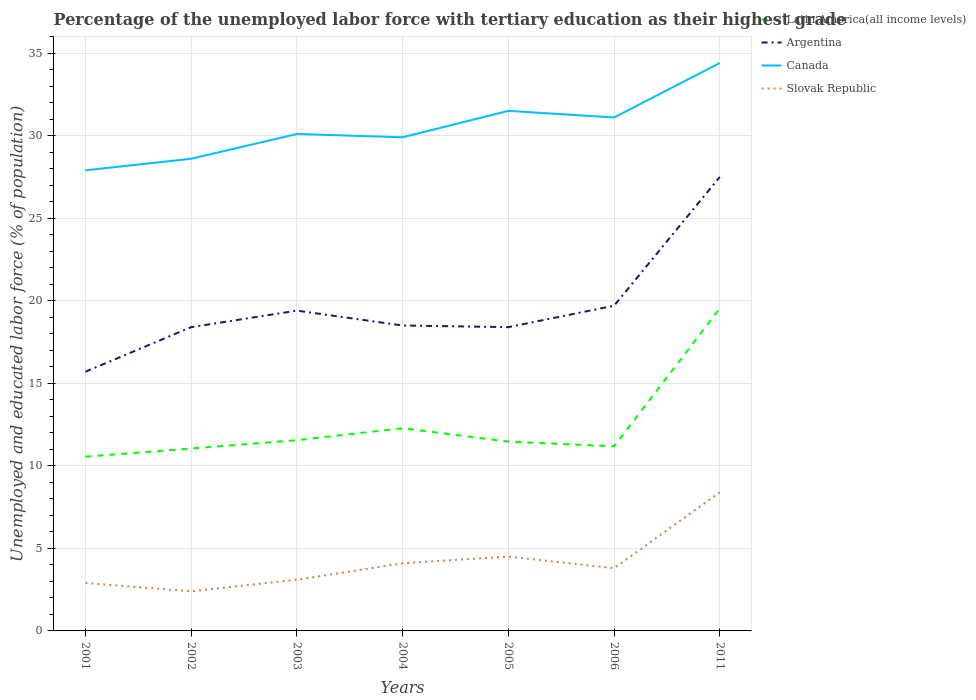Across all years, what is the maximum percentage of the unemployed labor force with tertiary education in Canada?
Provide a succinct answer. 27.9. In which year was the percentage of the unemployed labor force with tertiary education in Latin America(all income levels) maximum?
Your answer should be very brief. 2001. What is the total percentage of the unemployed labor force with tertiary education in Slovak Republic in the graph?
Offer a very short reply. -2.1. What is the difference between the highest and the second highest percentage of the unemployed labor force with tertiary education in Canada?
Provide a succinct answer. 6.5. What is the difference between the highest and the lowest percentage of the unemployed labor force with tertiary education in Canada?
Your response must be concise. 3. Where does the legend appear in the graph?
Offer a terse response. Top right. How many legend labels are there?
Keep it short and to the point. 4. What is the title of the graph?
Give a very brief answer. Percentage of the unemployed labor force with tertiary education as their highest grade. What is the label or title of the X-axis?
Ensure brevity in your answer.  Years. What is the label or title of the Y-axis?
Provide a succinct answer. Unemployed and educated labor force (% of population). What is the Unemployed and educated labor force (% of population) of Latin America(all income levels) in 2001?
Ensure brevity in your answer.  10.55. What is the Unemployed and educated labor force (% of population) in Argentina in 2001?
Ensure brevity in your answer.  15.7. What is the Unemployed and educated labor force (% of population) of Canada in 2001?
Provide a succinct answer. 27.9. What is the Unemployed and educated labor force (% of population) in Slovak Republic in 2001?
Give a very brief answer. 2.9. What is the Unemployed and educated labor force (% of population) of Latin America(all income levels) in 2002?
Keep it short and to the point. 11.05. What is the Unemployed and educated labor force (% of population) of Argentina in 2002?
Offer a very short reply. 18.4. What is the Unemployed and educated labor force (% of population) in Canada in 2002?
Keep it short and to the point. 28.6. What is the Unemployed and educated labor force (% of population) in Slovak Republic in 2002?
Make the answer very short. 2.4. What is the Unemployed and educated labor force (% of population) in Latin America(all income levels) in 2003?
Provide a short and direct response. 11.55. What is the Unemployed and educated labor force (% of population) of Argentina in 2003?
Make the answer very short. 19.4. What is the Unemployed and educated labor force (% of population) of Canada in 2003?
Ensure brevity in your answer.  30.1. What is the Unemployed and educated labor force (% of population) of Slovak Republic in 2003?
Offer a very short reply. 3.1. What is the Unemployed and educated labor force (% of population) in Latin America(all income levels) in 2004?
Offer a very short reply. 12.28. What is the Unemployed and educated labor force (% of population) of Canada in 2004?
Offer a terse response. 29.9. What is the Unemployed and educated labor force (% of population) of Slovak Republic in 2004?
Make the answer very short. 4.1. What is the Unemployed and educated labor force (% of population) of Latin America(all income levels) in 2005?
Your response must be concise. 11.46. What is the Unemployed and educated labor force (% of population) of Argentina in 2005?
Keep it short and to the point. 18.4. What is the Unemployed and educated labor force (% of population) in Canada in 2005?
Offer a very short reply. 31.5. What is the Unemployed and educated labor force (% of population) in Latin America(all income levels) in 2006?
Ensure brevity in your answer.  11.18. What is the Unemployed and educated labor force (% of population) of Argentina in 2006?
Keep it short and to the point. 19.7. What is the Unemployed and educated labor force (% of population) of Canada in 2006?
Ensure brevity in your answer.  31.1. What is the Unemployed and educated labor force (% of population) in Slovak Republic in 2006?
Ensure brevity in your answer.  3.8. What is the Unemployed and educated labor force (% of population) in Latin America(all income levels) in 2011?
Provide a succinct answer. 19.54. What is the Unemployed and educated labor force (% of population) in Canada in 2011?
Provide a short and direct response. 34.4. What is the Unemployed and educated labor force (% of population) of Slovak Republic in 2011?
Make the answer very short. 8.4. Across all years, what is the maximum Unemployed and educated labor force (% of population) in Latin America(all income levels)?
Your response must be concise. 19.54. Across all years, what is the maximum Unemployed and educated labor force (% of population) in Canada?
Offer a terse response. 34.4. Across all years, what is the maximum Unemployed and educated labor force (% of population) in Slovak Republic?
Make the answer very short. 8.4. Across all years, what is the minimum Unemployed and educated labor force (% of population) in Latin America(all income levels)?
Provide a succinct answer. 10.55. Across all years, what is the minimum Unemployed and educated labor force (% of population) of Argentina?
Provide a succinct answer. 15.7. Across all years, what is the minimum Unemployed and educated labor force (% of population) of Canada?
Provide a succinct answer. 27.9. Across all years, what is the minimum Unemployed and educated labor force (% of population) of Slovak Republic?
Ensure brevity in your answer.  2.4. What is the total Unemployed and educated labor force (% of population) of Latin America(all income levels) in the graph?
Your answer should be compact. 87.62. What is the total Unemployed and educated labor force (% of population) of Argentina in the graph?
Give a very brief answer. 137.6. What is the total Unemployed and educated labor force (% of population) of Canada in the graph?
Your answer should be compact. 213.5. What is the total Unemployed and educated labor force (% of population) of Slovak Republic in the graph?
Provide a short and direct response. 29.2. What is the difference between the Unemployed and educated labor force (% of population) in Latin America(all income levels) in 2001 and that in 2002?
Provide a succinct answer. -0.5. What is the difference between the Unemployed and educated labor force (% of population) in Argentina in 2001 and that in 2002?
Provide a short and direct response. -2.7. What is the difference between the Unemployed and educated labor force (% of population) of Canada in 2001 and that in 2002?
Your response must be concise. -0.7. What is the difference between the Unemployed and educated labor force (% of population) in Latin America(all income levels) in 2001 and that in 2003?
Keep it short and to the point. -1. What is the difference between the Unemployed and educated labor force (% of population) in Argentina in 2001 and that in 2003?
Make the answer very short. -3.7. What is the difference between the Unemployed and educated labor force (% of population) of Canada in 2001 and that in 2003?
Provide a succinct answer. -2.2. What is the difference between the Unemployed and educated labor force (% of population) of Slovak Republic in 2001 and that in 2003?
Your response must be concise. -0.2. What is the difference between the Unemployed and educated labor force (% of population) of Latin America(all income levels) in 2001 and that in 2004?
Provide a succinct answer. -1.73. What is the difference between the Unemployed and educated labor force (% of population) in Argentina in 2001 and that in 2004?
Your response must be concise. -2.8. What is the difference between the Unemployed and educated labor force (% of population) in Canada in 2001 and that in 2004?
Your answer should be very brief. -2. What is the difference between the Unemployed and educated labor force (% of population) of Slovak Republic in 2001 and that in 2004?
Give a very brief answer. -1.2. What is the difference between the Unemployed and educated labor force (% of population) in Latin America(all income levels) in 2001 and that in 2005?
Keep it short and to the point. -0.91. What is the difference between the Unemployed and educated labor force (% of population) of Argentina in 2001 and that in 2005?
Offer a terse response. -2.7. What is the difference between the Unemployed and educated labor force (% of population) in Canada in 2001 and that in 2005?
Your answer should be compact. -3.6. What is the difference between the Unemployed and educated labor force (% of population) of Latin America(all income levels) in 2001 and that in 2006?
Offer a terse response. -0.63. What is the difference between the Unemployed and educated labor force (% of population) in Argentina in 2001 and that in 2006?
Your response must be concise. -4. What is the difference between the Unemployed and educated labor force (% of population) of Slovak Republic in 2001 and that in 2006?
Your answer should be very brief. -0.9. What is the difference between the Unemployed and educated labor force (% of population) in Latin America(all income levels) in 2001 and that in 2011?
Offer a very short reply. -8.98. What is the difference between the Unemployed and educated labor force (% of population) of Argentina in 2001 and that in 2011?
Keep it short and to the point. -11.8. What is the difference between the Unemployed and educated labor force (% of population) of Canada in 2001 and that in 2011?
Provide a succinct answer. -6.5. What is the difference between the Unemployed and educated labor force (% of population) of Latin America(all income levels) in 2002 and that in 2003?
Offer a terse response. -0.51. What is the difference between the Unemployed and educated labor force (% of population) of Latin America(all income levels) in 2002 and that in 2004?
Offer a terse response. -1.23. What is the difference between the Unemployed and educated labor force (% of population) in Argentina in 2002 and that in 2004?
Ensure brevity in your answer.  -0.1. What is the difference between the Unemployed and educated labor force (% of population) of Slovak Republic in 2002 and that in 2004?
Provide a succinct answer. -1.7. What is the difference between the Unemployed and educated labor force (% of population) of Latin America(all income levels) in 2002 and that in 2005?
Ensure brevity in your answer.  -0.42. What is the difference between the Unemployed and educated labor force (% of population) of Argentina in 2002 and that in 2005?
Your answer should be very brief. 0. What is the difference between the Unemployed and educated labor force (% of population) in Canada in 2002 and that in 2005?
Provide a succinct answer. -2.9. What is the difference between the Unemployed and educated labor force (% of population) of Slovak Republic in 2002 and that in 2005?
Keep it short and to the point. -2.1. What is the difference between the Unemployed and educated labor force (% of population) of Latin America(all income levels) in 2002 and that in 2006?
Provide a short and direct response. -0.14. What is the difference between the Unemployed and educated labor force (% of population) of Argentina in 2002 and that in 2006?
Provide a succinct answer. -1.3. What is the difference between the Unemployed and educated labor force (% of population) in Slovak Republic in 2002 and that in 2006?
Ensure brevity in your answer.  -1.4. What is the difference between the Unemployed and educated labor force (% of population) in Latin America(all income levels) in 2002 and that in 2011?
Offer a very short reply. -8.49. What is the difference between the Unemployed and educated labor force (% of population) of Latin America(all income levels) in 2003 and that in 2004?
Provide a succinct answer. -0.73. What is the difference between the Unemployed and educated labor force (% of population) of Argentina in 2003 and that in 2004?
Your response must be concise. 0.9. What is the difference between the Unemployed and educated labor force (% of population) in Canada in 2003 and that in 2004?
Your answer should be very brief. 0.2. What is the difference between the Unemployed and educated labor force (% of population) of Slovak Republic in 2003 and that in 2004?
Provide a short and direct response. -1. What is the difference between the Unemployed and educated labor force (% of population) in Latin America(all income levels) in 2003 and that in 2005?
Offer a very short reply. 0.09. What is the difference between the Unemployed and educated labor force (% of population) of Canada in 2003 and that in 2005?
Give a very brief answer. -1.4. What is the difference between the Unemployed and educated labor force (% of population) of Latin America(all income levels) in 2003 and that in 2006?
Make the answer very short. 0.37. What is the difference between the Unemployed and educated labor force (% of population) in Canada in 2003 and that in 2006?
Make the answer very short. -1. What is the difference between the Unemployed and educated labor force (% of population) of Latin America(all income levels) in 2003 and that in 2011?
Offer a terse response. -7.98. What is the difference between the Unemployed and educated labor force (% of population) of Slovak Republic in 2003 and that in 2011?
Provide a succinct answer. -5.3. What is the difference between the Unemployed and educated labor force (% of population) of Latin America(all income levels) in 2004 and that in 2005?
Provide a succinct answer. 0.81. What is the difference between the Unemployed and educated labor force (% of population) of Argentina in 2004 and that in 2005?
Keep it short and to the point. 0.1. What is the difference between the Unemployed and educated labor force (% of population) in Slovak Republic in 2004 and that in 2005?
Offer a terse response. -0.4. What is the difference between the Unemployed and educated labor force (% of population) of Latin America(all income levels) in 2004 and that in 2006?
Your response must be concise. 1.09. What is the difference between the Unemployed and educated labor force (% of population) in Argentina in 2004 and that in 2006?
Your answer should be very brief. -1.2. What is the difference between the Unemployed and educated labor force (% of population) of Latin America(all income levels) in 2004 and that in 2011?
Offer a terse response. -7.26. What is the difference between the Unemployed and educated labor force (% of population) in Canada in 2004 and that in 2011?
Make the answer very short. -4.5. What is the difference between the Unemployed and educated labor force (% of population) of Slovak Republic in 2004 and that in 2011?
Give a very brief answer. -4.3. What is the difference between the Unemployed and educated labor force (% of population) in Latin America(all income levels) in 2005 and that in 2006?
Your answer should be compact. 0.28. What is the difference between the Unemployed and educated labor force (% of population) of Canada in 2005 and that in 2006?
Keep it short and to the point. 0.4. What is the difference between the Unemployed and educated labor force (% of population) in Slovak Republic in 2005 and that in 2006?
Offer a terse response. 0.7. What is the difference between the Unemployed and educated labor force (% of population) of Latin America(all income levels) in 2005 and that in 2011?
Make the answer very short. -8.07. What is the difference between the Unemployed and educated labor force (% of population) of Argentina in 2005 and that in 2011?
Offer a terse response. -9.1. What is the difference between the Unemployed and educated labor force (% of population) in Canada in 2005 and that in 2011?
Give a very brief answer. -2.9. What is the difference between the Unemployed and educated labor force (% of population) in Slovak Republic in 2005 and that in 2011?
Your answer should be compact. -3.9. What is the difference between the Unemployed and educated labor force (% of population) in Latin America(all income levels) in 2006 and that in 2011?
Your answer should be compact. -8.35. What is the difference between the Unemployed and educated labor force (% of population) of Argentina in 2006 and that in 2011?
Offer a very short reply. -7.8. What is the difference between the Unemployed and educated labor force (% of population) in Slovak Republic in 2006 and that in 2011?
Offer a terse response. -4.6. What is the difference between the Unemployed and educated labor force (% of population) in Latin America(all income levels) in 2001 and the Unemployed and educated labor force (% of population) in Argentina in 2002?
Give a very brief answer. -7.85. What is the difference between the Unemployed and educated labor force (% of population) in Latin America(all income levels) in 2001 and the Unemployed and educated labor force (% of population) in Canada in 2002?
Give a very brief answer. -18.05. What is the difference between the Unemployed and educated labor force (% of population) of Latin America(all income levels) in 2001 and the Unemployed and educated labor force (% of population) of Slovak Republic in 2002?
Your response must be concise. 8.15. What is the difference between the Unemployed and educated labor force (% of population) in Latin America(all income levels) in 2001 and the Unemployed and educated labor force (% of population) in Argentina in 2003?
Make the answer very short. -8.85. What is the difference between the Unemployed and educated labor force (% of population) in Latin America(all income levels) in 2001 and the Unemployed and educated labor force (% of population) in Canada in 2003?
Provide a short and direct response. -19.55. What is the difference between the Unemployed and educated labor force (% of population) of Latin America(all income levels) in 2001 and the Unemployed and educated labor force (% of population) of Slovak Republic in 2003?
Keep it short and to the point. 7.45. What is the difference between the Unemployed and educated labor force (% of population) in Argentina in 2001 and the Unemployed and educated labor force (% of population) in Canada in 2003?
Provide a succinct answer. -14.4. What is the difference between the Unemployed and educated labor force (% of population) of Argentina in 2001 and the Unemployed and educated labor force (% of population) of Slovak Republic in 2003?
Offer a terse response. 12.6. What is the difference between the Unemployed and educated labor force (% of population) in Canada in 2001 and the Unemployed and educated labor force (% of population) in Slovak Republic in 2003?
Offer a very short reply. 24.8. What is the difference between the Unemployed and educated labor force (% of population) of Latin America(all income levels) in 2001 and the Unemployed and educated labor force (% of population) of Argentina in 2004?
Your answer should be very brief. -7.95. What is the difference between the Unemployed and educated labor force (% of population) of Latin America(all income levels) in 2001 and the Unemployed and educated labor force (% of population) of Canada in 2004?
Offer a terse response. -19.35. What is the difference between the Unemployed and educated labor force (% of population) in Latin America(all income levels) in 2001 and the Unemployed and educated labor force (% of population) in Slovak Republic in 2004?
Your answer should be very brief. 6.45. What is the difference between the Unemployed and educated labor force (% of population) of Argentina in 2001 and the Unemployed and educated labor force (% of population) of Slovak Republic in 2004?
Your answer should be very brief. 11.6. What is the difference between the Unemployed and educated labor force (% of population) of Canada in 2001 and the Unemployed and educated labor force (% of population) of Slovak Republic in 2004?
Keep it short and to the point. 23.8. What is the difference between the Unemployed and educated labor force (% of population) of Latin America(all income levels) in 2001 and the Unemployed and educated labor force (% of population) of Argentina in 2005?
Give a very brief answer. -7.85. What is the difference between the Unemployed and educated labor force (% of population) in Latin America(all income levels) in 2001 and the Unemployed and educated labor force (% of population) in Canada in 2005?
Ensure brevity in your answer.  -20.95. What is the difference between the Unemployed and educated labor force (% of population) of Latin America(all income levels) in 2001 and the Unemployed and educated labor force (% of population) of Slovak Republic in 2005?
Make the answer very short. 6.05. What is the difference between the Unemployed and educated labor force (% of population) of Argentina in 2001 and the Unemployed and educated labor force (% of population) of Canada in 2005?
Your answer should be very brief. -15.8. What is the difference between the Unemployed and educated labor force (% of population) of Canada in 2001 and the Unemployed and educated labor force (% of population) of Slovak Republic in 2005?
Offer a terse response. 23.4. What is the difference between the Unemployed and educated labor force (% of population) of Latin America(all income levels) in 2001 and the Unemployed and educated labor force (% of population) of Argentina in 2006?
Ensure brevity in your answer.  -9.15. What is the difference between the Unemployed and educated labor force (% of population) in Latin America(all income levels) in 2001 and the Unemployed and educated labor force (% of population) in Canada in 2006?
Your answer should be compact. -20.55. What is the difference between the Unemployed and educated labor force (% of population) in Latin America(all income levels) in 2001 and the Unemployed and educated labor force (% of population) in Slovak Republic in 2006?
Your answer should be compact. 6.75. What is the difference between the Unemployed and educated labor force (% of population) in Argentina in 2001 and the Unemployed and educated labor force (% of population) in Canada in 2006?
Keep it short and to the point. -15.4. What is the difference between the Unemployed and educated labor force (% of population) of Argentina in 2001 and the Unemployed and educated labor force (% of population) of Slovak Republic in 2006?
Your answer should be very brief. 11.9. What is the difference between the Unemployed and educated labor force (% of population) of Canada in 2001 and the Unemployed and educated labor force (% of population) of Slovak Republic in 2006?
Make the answer very short. 24.1. What is the difference between the Unemployed and educated labor force (% of population) of Latin America(all income levels) in 2001 and the Unemployed and educated labor force (% of population) of Argentina in 2011?
Offer a very short reply. -16.95. What is the difference between the Unemployed and educated labor force (% of population) in Latin America(all income levels) in 2001 and the Unemployed and educated labor force (% of population) in Canada in 2011?
Give a very brief answer. -23.85. What is the difference between the Unemployed and educated labor force (% of population) of Latin America(all income levels) in 2001 and the Unemployed and educated labor force (% of population) of Slovak Republic in 2011?
Offer a very short reply. 2.15. What is the difference between the Unemployed and educated labor force (% of population) in Argentina in 2001 and the Unemployed and educated labor force (% of population) in Canada in 2011?
Your answer should be compact. -18.7. What is the difference between the Unemployed and educated labor force (% of population) of Argentina in 2001 and the Unemployed and educated labor force (% of population) of Slovak Republic in 2011?
Provide a short and direct response. 7.3. What is the difference between the Unemployed and educated labor force (% of population) in Latin America(all income levels) in 2002 and the Unemployed and educated labor force (% of population) in Argentina in 2003?
Your response must be concise. -8.35. What is the difference between the Unemployed and educated labor force (% of population) of Latin America(all income levels) in 2002 and the Unemployed and educated labor force (% of population) of Canada in 2003?
Offer a very short reply. -19.05. What is the difference between the Unemployed and educated labor force (% of population) of Latin America(all income levels) in 2002 and the Unemployed and educated labor force (% of population) of Slovak Republic in 2003?
Keep it short and to the point. 7.95. What is the difference between the Unemployed and educated labor force (% of population) of Argentina in 2002 and the Unemployed and educated labor force (% of population) of Slovak Republic in 2003?
Provide a succinct answer. 15.3. What is the difference between the Unemployed and educated labor force (% of population) in Latin America(all income levels) in 2002 and the Unemployed and educated labor force (% of population) in Argentina in 2004?
Ensure brevity in your answer.  -7.45. What is the difference between the Unemployed and educated labor force (% of population) of Latin America(all income levels) in 2002 and the Unemployed and educated labor force (% of population) of Canada in 2004?
Ensure brevity in your answer.  -18.85. What is the difference between the Unemployed and educated labor force (% of population) in Latin America(all income levels) in 2002 and the Unemployed and educated labor force (% of population) in Slovak Republic in 2004?
Provide a succinct answer. 6.95. What is the difference between the Unemployed and educated labor force (% of population) in Canada in 2002 and the Unemployed and educated labor force (% of population) in Slovak Republic in 2004?
Your response must be concise. 24.5. What is the difference between the Unemployed and educated labor force (% of population) of Latin America(all income levels) in 2002 and the Unemployed and educated labor force (% of population) of Argentina in 2005?
Your answer should be very brief. -7.35. What is the difference between the Unemployed and educated labor force (% of population) in Latin America(all income levels) in 2002 and the Unemployed and educated labor force (% of population) in Canada in 2005?
Your answer should be compact. -20.45. What is the difference between the Unemployed and educated labor force (% of population) of Latin America(all income levels) in 2002 and the Unemployed and educated labor force (% of population) of Slovak Republic in 2005?
Ensure brevity in your answer.  6.55. What is the difference between the Unemployed and educated labor force (% of population) in Argentina in 2002 and the Unemployed and educated labor force (% of population) in Canada in 2005?
Keep it short and to the point. -13.1. What is the difference between the Unemployed and educated labor force (% of population) in Canada in 2002 and the Unemployed and educated labor force (% of population) in Slovak Republic in 2005?
Your answer should be compact. 24.1. What is the difference between the Unemployed and educated labor force (% of population) in Latin America(all income levels) in 2002 and the Unemployed and educated labor force (% of population) in Argentina in 2006?
Offer a terse response. -8.65. What is the difference between the Unemployed and educated labor force (% of population) in Latin America(all income levels) in 2002 and the Unemployed and educated labor force (% of population) in Canada in 2006?
Offer a terse response. -20.05. What is the difference between the Unemployed and educated labor force (% of population) of Latin America(all income levels) in 2002 and the Unemployed and educated labor force (% of population) of Slovak Republic in 2006?
Offer a terse response. 7.25. What is the difference between the Unemployed and educated labor force (% of population) of Argentina in 2002 and the Unemployed and educated labor force (% of population) of Canada in 2006?
Give a very brief answer. -12.7. What is the difference between the Unemployed and educated labor force (% of population) in Canada in 2002 and the Unemployed and educated labor force (% of population) in Slovak Republic in 2006?
Keep it short and to the point. 24.8. What is the difference between the Unemployed and educated labor force (% of population) in Latin America(all income levels) in 2002 and the Unemployed and educated labor force (% of population) in Argentina in 2011?
Make the answer very short. -16.45. What is the difference between the Unemployed and educated labor force (% of population) of Latin America(all income levels) in 2002 and the Unemployed and educated labor force (% of population) of Canada in 2011?
Your response must be concise. -23.35. What is the difference between the Unemployed and educated labor force (% of population) in Latin America(all income levels) in 2002 and the Unemployed and educated labor force (% of population) in Slovak Republic in 2011?
Offer a terse response. 2.65. What is the difference between the Unemployed and educated labor force (% of population) in Argentina in 2002 and the Unemployed and educated labor force (% of population) in Canada in 2011?
Offer a very short reply. -16. What is the difference between the Unemployed and educated labor force (% of population) in Canada in 2002 and the Unemployed and educated labor force (% of population) in Slovak Republic in 2011?
Your response must be concise. 20.2. What is the difference between the Unemployed and educated labor force (% of population) of Latin America(all income levels) in 2003 and the Unemployed and educated labor force (% of population) of Argentina in 2004?
Offer a very short reply. -6.95. What is the difference between the Unemployed and educated labor force (% of population) in Latin America(all income levels) in 2003 and the Unemployed and educated labor force (% of population) in Canada in 2004?
Make the answer very short. -18.35. What is the difference between the Unemployed and educated labor force (% of population) of Latin America(all income levels) in 2003 and the Unemployed and educated labor force (% of population) of Slovak Republic in 2004?
Offer a very short reply. 7.45. What is the difference between the Unemployed and educated labor force (% of population) in Argentina in 2003 and the Unemployed and educated labor force (% of population) in Canada in 2004?
Make the answer very short. -10.5. What is the difference between the Unemployed and educated labor force (% of population) in Argentina in 2003 and the Unemployed and educated labor force (% of population) in Slovak Republic in 2004?
Provide a short and direct response. 15.3. What is the difference between the Unemployed and educated labor force (% of population) of Latin America(all income levels) in 2003 and the Unemployed and educated labor force (% of population) of Argentina in 2005?
Provide a succinct answer. -6.85. What is the difference between the Unemployed and educated labor force (% of population) in Latin America(all income levels) in 2003 and the Unemployed and educated labor force (% of population) in Canada in 2005?
Ensure brevity in your answer.  -19.95. What is the difference between the Unemployed and educated labor force (% of population) of Latin America(all income levels) in 2003 and the Unemployed and educated labor force (% of population) of Slovak Republic in 2005?
Make the answer very short. 7.05. What is the difference between the Unemployed and educated labor force (% of population) in Argentina in 2003 and the Unemployed and educated labor force (% of population) in Canada in 2005?
Provide a short and direct response. -12.1. What is the difference between the Unemployed and educated labor force (% of population) in Canada in 2003 and the Unemployed and educated labor force (% of population) in Slovak Republic in 2005?
Keep it short and to the point. 25.6. What is the difference between the Unemployed and educated labor force (% of population) of Latin America(all income levels) in 2003 and the Unemployed and educated labor force (% of population) of Argentina in 2006?
Offer a terse response. -8.15. What is the difference between the Unemployed and educated labor force (% of population) in Latin America(all income levels) in 2003 and the Unemployed and educated labor force (% of population) in Canada in 2006?
Provide a succinct answer. -19.55. What is the difference between the Unemployed and educated labor force (% of population) of Latin America(all income levels) in 2003 and the Unemployed and educated labor force (% of population) of Slovak Republic in 2006?
Your answer should be compact. 7.75. What is the difference between the Unemployed and educated labor force (% of population) in Argentina in 2003 and the Unemployed and educated labor force (% of population) in Slovak Republic in 2006?
Your answer should be very brief. 15.6. What is the difference between the Unemployed and educated labor force (% of population) in Canada in 2003 and the Unemployed and educated labor force (% of population) in Slovak Republic in 2006?
Offer a terse response. 26.3. What is the difference between the Unemployed and educated labor force (% of population) in Latin America(all income levels) in 2003 and the Unemployed and educated labor force (% of population) in Argentina in 2011?
Offer a very short reply. -15.95. What is the difference between the Unemployed and educated labor force (% of population) in Latin America(all income levels) in 2003 and the Unemployed and educated labor force (% of population) in Canada in 2011?
Offer a very short reply. -22.85. What is the difference between the Unemployed and educated labor force (% of population) in Latin America(all income levels) in 2003 and the Unemployed and educated labor force (% of population) in Slovak Republic in 2011?
Give a very brief answer. 3.15. What is the difference between the Unemployed and educated labor force (% of population) of Canada in 2003 and the Unemployed and educated labor force (% of population) of Slovak Republic in 2011?
Your answer should be very brief. 21.7. What is the difference between the Unemployed and educated labor force (% of population) in Latin America(all income levels) in 2004 and the Unemployed and educated labor force (% of population) in Argentina in 2005?
Make the answer very short. -6.12. What is the difference between the Unemployed and educated labor force (% of population) in Latin America(all income levels) in 2004 and the Unemployed and educated labor force (% of population) in Canada in 2005?
Your answer should be compact. -19.22. What is the difference between the Unemployed and educated labor force (% of population) of Latin America(all income levels) in 2004 and the Unemployed and educated labor force (% of population) of Slovak Republic in 2005?
Make the answer very short. 7.78. What is the difference between the Unemployed and educated labor force (% of population) in Argentina in 2004 and the Unemployed and educated labor force (% of population) in Canada in 2005?
Make the answer very short. -13. What is the difference between the Unemployed and educated labor force (% of population) of Argentina in 2004 and the Unemployed and educated labor force (% of population) of Slovak Republic in 2005?
Offer a very short reply. 14. What is the difference between the Unemployed and educated labor force (% of population) of Canada in 2004 and the Unemployed and educated labor force (% of population) of Slovak Republic in 2005?
Give a very brief answer. 25.4. What is the difference between the Unemployed and educated labor force (% of population) of Latin America(all income levels) in 2004 and the Unemployed and educated labor force (% of population) of Argentina in 2006?
Keep it short and to the point. -7.42. What is the difference between the Unemployed and educated labor force (% of population) of Latin America(all income levels) in 2004 and the Unemployed and educated labor force (% of population) of Canada in 2006?
Offer a very short reply. -18.82. What is the difference between the Unemployed and educated labor force (% of population) in Latin America(all income levels) in 2004 and the Unemployed and educated labor force (% of population) in Slovak Republic in 2006?
Make the answer very short. 8.48. What is the difference between the Unemployed and educated labor force (% of population) of Argentina in 2004 and the Unemployed and educated labor force (% of population) of Canada in 2006?
Provide a short and direct response. -12.6. What is the difference between the Unemployed and educated labor force (% of population) in Canada in 2004 and the Unemployed and educated labor force (% of population) in Slovak Republic in 2006?
Provide a short and direct response. 26.1. What is the difference between the Unemployed and educated labor force (% of population) in Latin America(all income levels) in 2004 and the Unemployed and educated labor force (% of population) in Argentina in 2011?
Give a very brief answer. -15.22. What is the difference between the Unemployed and educated labor force (% of population) in Latin America(all income levels) in 2004 and the Unemployed and educated labor force (% of population) in Canada in 2011?
Your answer should be very brief. -22.12. What is the difference between the Unemployed and educated labor force (% of population) in Latin America(all income levels) in 2004 and the Unemployed and educated labor force (% of population) in Slovak Republic in 2011?
Give a very brief answer. 3.88. What is the difference between the Unemployed and educated labor force (% of population) of Argentina in 2004 and the Unemployed and educated labor force (% of population) of Canada in 2011?
Your response must be concise. -15.9. What is the difference between the Unemployed and educated labor force (% of population) in Canada in 2004 and the Unemployed and educated labor force (% of population) in Slovak Republic in 2011?
Offer a very short reply. 21.5. What is the difference between the Unemployed and educated labor force (% of population) in Latin America(all income levels) in 2005 and the Unemployed and educated labor force (% of population) in Argentina in 2006?
Provide a succinct answer. -8.24. What is the difference between the Unemployed and educated labor force (% of population) of Latin America(all income levels) in 2005 and the Unemployed and educated labor force (% of population) of Canada in 2006?
Offer a very short reply. -19.64. What is the difference between the Unemployed and educated labor force (% of population) of Latin America(all income levels) in 2005 and the Unemployed and educated labor force (% of population) of Slovak Republic in 2006?
Offer a very short reply. 7.66. What is the difference between the Unemployed and educated labor force (% of population) in Argentina in 2005 and the Unemployed and educated labor force (% of population) in Canada in 2006?
Make the answer very short. -12.7. What is the difference between the Unemployed and educated labor force (% of population) in Argentina in 2005 and the Unemployed and educated labor force (% of population) in Slovak Republic in 2006?
Your answer should be very brief. 14.6. What is the difference between the Unemployed and educated labor force (% of population) of Canada in 2005 and the Unemployed and educated labor force (% of population) of Slovak Republic in 2006?
Your answer should be compact. 27.7. What is the difference between the Unemployed and educated labor force (% of population) of Latin America(all income levels) in 2005 and the Unemployed and educated labor force (% of population) of Argentina in 2011?
Offer a terse response. -16.04. What is the difference between the Unemployed and educated labor force (% of population) in Latin America(all income levels) in 2005 and the Unemployed and educated labor force (% of population) in Canada in 2011?
Your answer should be compact. -22.94. What is the difference between the Unemployed and educated labor force (% of population) in Latin America(all income levels) in 2005 and the Unemployed and educated labor force (% of population) in Slovak Republic in 2011?
Keep it short and to the point. 3.06. What is the difference between the Unemployed and educated labor force (% of population) in Canada in 2005 and the Unemployed and educated labor force (% of population) in Slovak Republic in 2011?
Provide a short and direct response. 23.1. What is the difference between the Unemployed and educated labor force (% of population) of Latin America(all income levels) in 2006 and the Unemployed and educated labor force (% of population) of Argentina in 2011?
Ensure brevity in your answer.  -16.32. What is the difference between the Unemployed and educated labor force (% of population) in Latin America(all income levels) in 2006 and the Unemployed and educated labor force (% of population) in Canada in 2011?
Your answer should be compact. -23.22. What is the difference between the Unemployed and educated labor force (% of population) of Latin America(all income levels) in 2006 and the Unemployed and educated labor force (% of population) of Slovak Republic in 2011?
Give a very brief answer. 2.78. What is the difference between the Unemployed and educated labor force (% of population) in Argentina in 2006 and the Unemployed and educated labor force (% of population) in Canada in 2011?
Provide a short and direct response. -14.7. What is the difference between the Unemployed and educated labor force (% of population) in Argentina in 2006 and the Unemployed and educated labor force (% of population) in Slovak Republic in 2011?
Ensure brevity in your answer.  11.3. What is the difference between the Unemployed and educated labor force (% of population) in Canada in 2006 and the Unemployed and educated labor force (% of population) in Slovak Republic in 2011?
Offer a terse response. 22.7. What is the average Unemployed and educated labor force (% of population) of Latin America(all income levels) per year?
Offer a terse response. 12.52. What is the average Unemployed and educated labor force (% of population) of Argentina per year?
Offer a very short reply. 19.66. What is the average Unemployed and educated labor force (% of population) in Canada per year?
Provide a succinct answer. 30.5. What is the average Unemployed and educated labor force (% of population) of Slovak Republic per year?
Offer a terse response. 4.17. In the year 2001, what is the difference between the Unemployed and educated labor force (% of population) in Latin America(all income levels) and Unemployed and educated labor force (% of population) in Argentina?
Keep it short and to the point. -5.15. In the year 2001, what is the difference between the Unemployed and educated labor force (% of population) in Latin America(all income levels) and Unemployed and educated labor force (% of population) in Canada?
Ensure brevity in your answer.  -17.35. In the year 2001, what is the difference between the Unemployed and educated labor force (% of population) in Latin America(all income levels) and Unemployed and educated labor force (% of population) in Slovak Republic?
Give a very brief answer. 7.65. In the year 2001, what is the difference between the Unemployed and educated labor force (% of population) of Argentina and Unemployed and educated labor force (% of population) of Canada?
Your answer should be compact. -12.2. In the year 2001, what is the difference between the Unemployed and educated labor force (% of population) of Argentina and Unemployed and educated labor force (% of population) of Slovak Republic?
Offer a very short reply. 12.8. In the year 2001, what is the difference between the Unemployed and educated labor force (% of population) in Canada and Unemployed and educated labor force (% of population) in Slovak Republic?
Your answer should be compact. 25. In the year 2002, what is the difference between the Unemployed and educated labor force (% of population) in Latin America(all income levels) and Unemployed and educated labor force (% of population) in Argentina?
Your answer should be compact. -7.35. In the year 2002, what is the difference between the Unemployed and educated labor force (% of population) in Latin America(all income levels) and Unemployed and educated labor force (% of population) in Canada?
Your answer should be very brief. -17.55. In the year 2002, what is the difference between the Unemployed and educated labor force (% of population) of Latin America(all income levels) and Unemployed and educated labor force (% of population) of Slovak Republic?
Provide a short and direct response. 8.65. In the year 2002, what is the difference between the Unemployed and educated labor force (% of population) in Canada and Unemployed and educated labor force (% of population) in Slovak Republic?
Give a very brief answer. 26.2. In the year 2003, what is the difference between the Unemployed and educated labor force (% of population) in Latin America(all income levels) and Unemployed and educated labor force (% of population) in Argentina?
Offer a terse response. -7.85. In the year 2003, what is the difference between the Unemployed and educated labor force (% of population) in Latin America(all income levels) and Unemployed and educated labor force (% of population) in Canada?
Make the answer very short. -18.55. In the year 2003, what is the difference between the Unemployed and educated labor force (% of population) of Latin America(all income levels) and Unemployed and educated labor force (% of population) of Slovak Republic?
Give a very brief answer. 8.45. In the year 2003, what is the difference between the Unemployed and educated labor force (% of population) of Argentina and Unemployed and educated labor force (% of population) of Slovak Republic?
Ensure brevity in your answer.  16.3. In the year 2004, what is the difference between the Unemployed and educated labor force (% of population) of Latin America(all income levels) and Unemployed and educated labor force (% of population) of Argentina?
Your response must be concise. -6.22. In the year 2004, what is the difference between the Unemployed and educated labor force (% of population) of Latin America(all income levels) and Unemployed and educated labor force (% of population) of Canada?
Make the answer very short. -17.62. In the year 2004, what is the difference between the Unemployed and educated labor force (% of population) in Latin America(all income levels) and Unemployed and educated labor force (% of population) in Slovak Republic?
Your response must be concise. 8.18. In the year 2004, what is the difference between the Unemployed and educated labor force (% of population) of Argentina and Unemployed and educated labor force (% of population) of Canada?
Make the answer very short. -11.4. In the year 2004, what is the difference between the Unemployed and educated labor force (% of population) in Argentina and Unemployed and educated labor force (% of population) in Slovak Republic?
Provide a short and direct response. 14.4. In the year 2004, what is the difference between the Unemployed and educated labor force (% of population) in Canada and Unemployed and educated labor force (% of population) in Slovak Republic?
Keep it short and to the point. 25.8. In the year 2005, what is the difference between the Unemployed and educated labor force (% of population) of Latin America(all income levels) and Unemployed and educated labor force (% of population) of Argentina?
Provide a succinct answer. -6.94. In the year 2005, what is the difference between the Unemployed and educated labor force (% of population) of Latin America(all income levels) and Unemployed and educated labor force (% of population) of Canada?
Your response must be concise. -20.04. In the year 2005, what is the difference between the Unemployed and educated labor force (% of population) of Latin America(all income levels) and Unemployed and educated labor force (% of population) of Slovak Republic?
Your response must be concise. 6.96. In the year 2005, what is the difference between the Unemployed and educated labor force (% of population) of Argentina and Unemployed and educated labor force (% of population) of Canada?
Provide a short and direct response. -13.1. In the year 2005, what is the difference between the Unemployed and educated labor force (% of population) of Argentina and Unemployed and educated labor force (% of population) of Slovak Republic?
Provide a short and direct response. 13.9. In the year 2005, what is the difference between the Unemployed and educated labor force (% of population) in Canada and Unemployed and educated labor force (% of population) in Slovak Republic?
Offer a very short reply. 27. In the year 2006, what is the difference between the Unemployed and educated labor force (% of population) of Latin America(all income levels) and Unemployed and educated labor force (% of population) of Argentina?
Offer a terse response. -8.52. In the year 2006, what is the difference between the Unemployed and educated labor force (% of population) in Latin America(all income levels) and Unemployed and educated labor force (% of population) in Canada?
Your response must be concise. -19.92. In the year 2006, what is the difference between the Unemployed and educated labor force (% of population) of Latin America(all income levels) and Unemployed and educated labor force (% of population) of Slovak Republic?
Provide a succinct answer. 7.38. In the year 2006, what is the difference between the Unemployed and educated labor force (% of population) in Argentina and Unemployed and educated labor force (% of population) in Canada?
Give a very brief answer. -11.4. In the year 2006, what is the difference between the Unemployed and educated labor force (% of population) in Argentina and Unemployed and educated labor force (% of population) in Slovak Republic?
Provide a succinct answer. 15.9. In the year 2006, what is the difference between the Unemployed and educated labor force (% of population) in Canada and Unemployed and educated labor force (% of population) in Slovak Republic?
Keep it short and to the point. 27.3. In the year 2011, what is the difference between the Unemployed and educated labor force (% of population) of Latin America(all income levels) and Unemployed and educated labor force (% of population) of Argentina?
Offer a terse response. -7.96. In the year 2011, what is the difference between the Unemployed and educated labor force (% of population) of Latin America(all income levels) and Unemployed and educated labor force (% of population) of Canada?
Your response must be concise. -14.86. In the year 2011, what is the difference between the Unemployed and educated labor force (% of population) of Latin America(all income levels) and Unemployed and educated labor force (% of population) of Slovak Republic?
Provide a succinct answer. 11.14. In the year 2011, what is the difference between the Unemployed and educated labor force (% of population) of Argentina and Unemployed and educated labor force (% of population) of Canada?
Provide a succinct answer. -6.9. In the year 2011, what is the difference between the Unemployed and educated labor force (% of population) of Argentina and Unemployed and educated labor force (% of population) of Slovak Republic?
Make the answer very short. 19.1. What is the ratio of the Unemployed and educated labor force (% of population) of Latin America(all income levels) in 2001 to that in 2002?
Provide a succinct answer. 0.96. What is the ratio of the Unemployed and educated labor force (% of population) of Argentina in 2001 to that in 2002?
Offer a very short reply. 0.85. What is the ratio of the Unemployed and educated labor force (% of population) in Canada in 2001 to that in 2002?
Ensure brevity in your answer.  0.98. What is the ratio of the Unemployed and educated labor force (% of population) in Slovak Republic in 2001 to that in 2002?
Offer a terse response. 1.21. What is the ratio of the Unemployed and educated labor force (% of population) in Latin America(all income levels) in 2001 to that in 2003?
Make the answer very short. 0.91. What is the ratio of the Unemployed and educated labor force (% of population) in Argentina in 2001 to that in 2003?
Your response must be concise. 0.81. What is the ratio of the Unemployed and educated labor force (% of population) of Canada in 2001 to that in 2003?
Give a very brief answer. 0.93. What is the ratio of the Unemployed and educated labor force (% of population) of Slovak Republic in 2001 to that in 2003?
Give a very brief answer. 0.94. What is the ratio of the Unemployed and educated labor force (% of population) in Latin America(all income levels) in 2001 to that in 2004?
Your answer should be compact. 0.86. What is the ratio of the Unemployed and educated labor force (% of population) in Argentina in 2001 to that in 2004?
Make the answer very short. 0.85. What is the ratio of the Unemployed and educated labor force (% of population) of Canada in 2001 to that in 2004?
Offer a terse response. 0.93. What is the ratio of the Unemployed and educated labor force (% of population) of Slovak Republic in 2001 to that in 2004?
Provide a short and direct response. 0.71. What is the ratio of the Unemployed and educated labor force (% of population) in Latin America(all income levels) in 2001 to that in 2005?
Provide a short and direct response. 0.92. What is the ratio of the Unemployed and educated labor force (% of population) in Argentina in 2001 to that in 2005?
Your answer should be very brief. 0.85. What is the ratio of the Unemployed and educated labor force (% of population) in Canada in 2001 to that in 2005?
Provide a short and direct response. 0.89. What is the ratio of the Unemployed and educated labor force (% of population) of Slovak Republic in 2001 to that in 2005?
Provide a short and direct response. 0.64. What is the ratio of the Unemployed and educated labor force (% of population) of Latin America(all income levels) in 2001 to that in 2006?
Your answer should be very brief. 0.94. What is the ratio of the Unemployed and educated labor force (% of population) of Argentina in 2001 to that in 2006?
Provide a succinct answer. 0.8. What is the ratio of the Unemployed and educated labor force (% of population) in Canada in 2001 to that in 2006?
Offer a terse response. 0.9. What is the ratio of the Unemployed and educated labor force (% of population) of Slovak Republic in 2001 to that in 2006?
Offer a very short reply. 0.76. What is the ratio of the Unemployed and educated labor force (% of population) of Latin America(all income levels) in 2001 to that in 2011?
Keep it short and to the point. 0.54. What is the ratio of the Unemployed and educated labor force (% of population) of Argentina in 2001 to that in 2011?
Provide a succinct answer. 0.57. What is the ratio of the Unemployed and educated labor force (% of population) in Canada in 2001 to that in 2011?
Provide a short and direct response. 0.81. What is the ratio of the Unemployed and educated labor force (% of population) of Slovak Republic in 2001 to that in 2011?
Keep it short and to the point. 0.35. What is the ratio of the Unemployed and educated labor force (% of population) of Latin America(all income levels) in 2002 to that in 2003?
Offer a terse response. 0.96. What is the ratio of the Unemployed and educated labor force (% of population) in Argentina in 2002 to that in 2003?
Give a very brief answer. 0.95. What is the ratio of the Unemployed and educated labor force (% of population) of Canada in 2002 to that in 2003?
Ensure brevity in your answer.  0.95. What is the ratio of the Unemployed and educated labor force (% of population) in Slovak Republic in 2002 to that in 2003?
Give a very brief answer. 0.77. What is the ratio of the Unemployed and educated labor force (% of population) in Latin America(all income levels) in 2002 to that in 2004?
Provide a succinct answer. 0.9. What is the ratio of the Unemployed and educated labor force (% of population) of Canada in 2002 to that in 2004?
Give a very brief answer. 0.96. What is the ratio of the Unemployed and educated labor force (% of population) in Slovak Republic in 2002 to that in 2004?
Your response must be concise. 0.59. What is the ratio of the Unemployed and educated labor force (% of population) in Latin America(all income levels) in 2002 to that in 2005?
Make the answer very short. 0.96. What is the ratio of the Unemployed and educated labor force (% of population) in Argentina in 2002 to that in 2005?
Provide a short and direct response. 1. What is the ratio of the Unemployed and educated labor force (% of population) of Canada in 2002 to that in 2005?
Provide a short and direct response. 0.91. What is the ratio of the Unemployed and educated labor force (% of population) in Slovak Republic in 2002 to that in 2005?
Your answer should be compact. 0.53. What is the ratio of the Unemployed and educated labor force (% of population) in Latin America(all income levels) in 2002 to that in 2006?
Provide a short and direct response. 0.99. What is the ratio of the Unemployed and educated labor force (% of population) of Argentina in 2002 to that in 2006?
Provide a succinct answer. 0.93. What is the ratio of the Unemployed and educated labor force (% of population) in Canada in 2002 to that in 2006?
Your answer should be compact. 0.92. What is the ratio of the Unemployed and educated labor force (% of population) in Slovak Republic in 2002 to that in 2006?
Your answer should be very brief. 0.63. What is the ratio of the Unemployed and educated labor force (% of population) in Latin America(all income levels) in 2002 to that in 2011?
Keep it short and to the point. 0.57. What is the ratio of the Unemployed and educated labor force (% of population) of Argentina in 2002 to that in 2011?
Offer a very short reply. 0.67. What is the ratio of the Unemployed and educated labor force (% of population) of Canada in 2002 to that in 2011?
Offer a terse response. 0.83. What is the ratio of the Unemployed and educated labor force (% of population) of Slovak Republic in 2002 to that in 2011?
Ensure brevity in your answer.  0.29. What is the ratio of the Unemployed and educated labor force (% of population) in Latin America(all income levels) in 2003 to that in 2004?
Provide a succinct answer. 0.94. What is the ratio of the Unemployed and educated labor force (% of population) in Argentina in 2003 to that in 2004?
Offer a very short reply. 1.05. What is the ratio of the Unemployed and educated labor force (% of population) of Canada in 2003 to that in 2004?
Keep it short and to the point. 1.01. What is the ratio of the Unemployed and educated labor force (% of population) in Slovak Republic in 2003 to that in 2004?
Your response must be concise. 0.76. What is the ratio of the Unemployed and educated labor force (% of population) in Latin America(all income levels) in 2003 to that in 2005?
Provide a short and direct response. 1.01. What is the ratio of the Unemployed and educated labor force (% of population) in Argentina in 2003 to that in 2005?
Provide a short and direct response. 1.05. What is the ratio of the Unemployed and educated labor force (% of population) of Canada in 2003 to that in 2005?
Your answer should be compact. 0.96. What is the ratio of the Unemployed and educated labor force (% of population) of Slovak Republic in 2003 to that in 2005?
Your answer should be very brief. 0.69. What is the ratio of the Unemployed and educated labor force (% of population) of Latin America(all income levels) in 2003 to that in 2006?
Provide a succinct answer. 1.03. What is the ratio of the Unemployed and educated labor force (% of population) of Canada in 2003 to that in 2006?
Offer a very short reply. 0.97. What is the ratio of the Unemployed and educated labor force (% of population) in Slovak Republic in 2003 to that in 2006?
Offer a terse response. 0.82. What is the ratio of the Unemployed and educated labor force (% of population) in Latin America(all income levels) in 2003 to that in 2011?
Ensure brevity in your answer.  0.59. What is the ratio of the Unemployed and educated labor force (% of population) of Argentina in 2003 to that in 2011?
Ensure brevity in your answer.  0.71. What is the ratio of the Unemployed and educated labor force (% of population) in Canada in 2003 to that in 2011?
Provide a short and direct response. 0.88. What is the ratio of the Unemployed and educated labor force (% of population) in Slovak Republic in 2003 to that in 2011?
Ensure brevity in your answer.  0.37. What is the ratio of the Unemployed and educated labor force (% of population) in Latin America(all income levels) in 2004 to that in 2005?
Provide a succinct answer. 1.07. What is the ratio of the Unemployed and educated labor force (% of population) in Argentina in 2004 to that in 2005?
Offer a very short reply. 1.01. What is the ratio of the Unemployed and educated labor force (% of population) of Canada in 2004 to that in 2005?
Provide a succinct answer. 0.95. What is the ratio of the Unemployed and educated labor force (% of population) in Slovak Republic in 2004 to that in 2005?
Provide a succinct answer. 0.91. What is the ratio of the Unemployed and educated labor force (% of population) in Latin America(all income levels) in 2004 to that in 2006?
Provide a succinct answer. 1.1. What is the ratio of the Unemployed and educated labor force (% of population) of Argentina in 2004 to that in 2006?
Your answer should be very brief. 0.94. What is the ratio of the Unemployed and educated labor force (% of population) in Canada in 2004 to that in 2006?
Keep it short and to the point. 0.96. What is the ratio of the Unemployed and educated labor force (% of population) of Slovak Republic in 2004 to that in 2006?
Provide a succinct answer. 1.08. What is the ratio of the Unemployed and educated labor force (% of population) of Latin America(all income levels) in 2004 to that in 2011?
Make the answer very short. 0.63. What is the ratio of the Unemployed and educated labor force (% of population) of Argentina in 2004 to that in 2011?
Ensure brevity in your answer.  0.67. What is the ratio of the Unemployed and educated labor force (% of population) in Canada in 2004 to that in 2011?
Your answer should be very brief. 0.87. What is the ratio of the Unemployed and educated labor force (% of population) in Slovak Republic in 2004 to that in 2011?
Your answer should be very brief. 0.49. What is the ratio of the Unemployed and educated labor force (% of population) in Latin America(all income levels) in 2005 to that in 2006?
Ensure brevity in your answer.  1.03. What is the ratio of the Unemployed and educated labor force (% of population) in Argentina in 2005 to that in 2006?
Your answer should be very brief. 0.93. What is the ratio of the Unemployed and educated labor force (% of population) in Canada in 2005 to that in 2006?
Provide a short and direct response. 1.01. What is the ratio of the Unemployed and educated labor force (% of population) of Slovak Republic in 2005 to that in 2006?
Your answer should be very brief. 1.18. What is the ratio of the Unemployed and educated labor force (% of population) of Latin America(all income levels) in 2005 to that in 2011?
Offer a very short reply. 0.59. What is the ratio of the Unemployed and educated labor force (% of population) in Argentina in 2005 to that in 2011?
Give a very brief answer. 0.67. What is the ratio of the Unemployed and educated labor force (% of population) of Canada in 2005 to that in 2011?
Provide a short and direct response. 0.92. What is the ratio of the Unemployed and educated labor force (% of population) in Slovak Republic in 2005 to that in 2011?
Give a very brief answer. 0.54. What is the ratio of the Unemployed and educated labor force (% of population) in Latin America(all income levels) in 2006 to that in 2011?
Your answer should be very brief. 0.57. What is the ratio of the Unemployed and educated labor force (% of population) in Argentina in 2006 to that in 2011?
Keep it short and to the point. 0.72. What is the ratio of the Unemployed and educated labor force (% of population) in Canada in 2006 to that in 2011?
Your answer should be compact. 0.9. What is the ratio of the Unemployed and educated labor force (% of population) in Slovak Republic in 2006 to that in 2011?
Provide a short and direct response. 0.45. What is the difference between the highest and the second highest Unemployed and educated labor force (% of population) in Latin America(all income levels)?
Make the answer very short. 7.26. What is the difference between the highest and the second highest Unemployed and educated labor force (% of population) of Canada?
Offer a very short reply. 2.9. What is the difference between the highest and the lowest Unemployed and educated labor force (% of population) of Latin America(all income levels)?
Keep it short and to the point. 8.98. What is the difference between the highest and the lowest Unemployed and educated labor force (% of population) in Slovak Republic?
Provide a short and direct response. 6. 